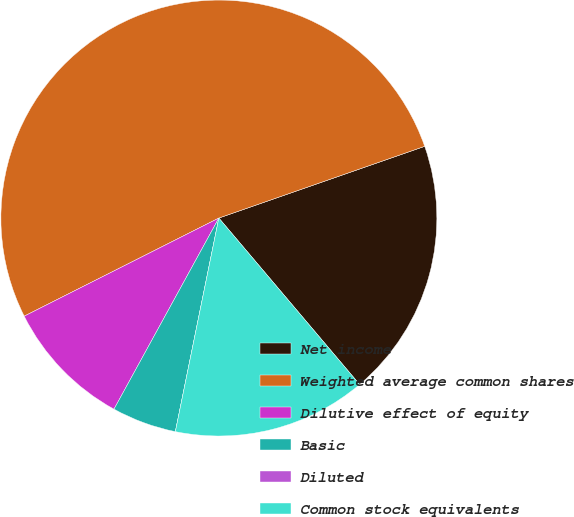Convert chart to OTSL. <chart><loc_0><loc_0><loc_500><loc_500><pie_chart><fcel>Net income<fcel>Weighted average common shares<fcel>Dilutive effect of equity<fcel>Basic<fcel>Diluted<fcel>Common stock equivalents<nl><fcel>19.16%<fcel>52.09%<fcel>9.58%<fcel>4.79%<fcel>0.0%<fcel>14.37%<nl></chart> 